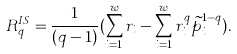<formula> <loc_0><loc_0><loc_500><loc_500>R _ { q } ^ { I S } = \frac { 1 } { ( q - 1 ) } ( \sum _ { i = 1 } ^ { w } r _ { i } - \sum _ { i = 1 } ^ { w } r _ { i } ^ { q } \widetilde { p } _ { i } ^ { 1 - q } ) .</formula> 